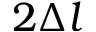<formula> <loc_0><loc_0><loc_500><loc_500>2 \Delta l</formula> 